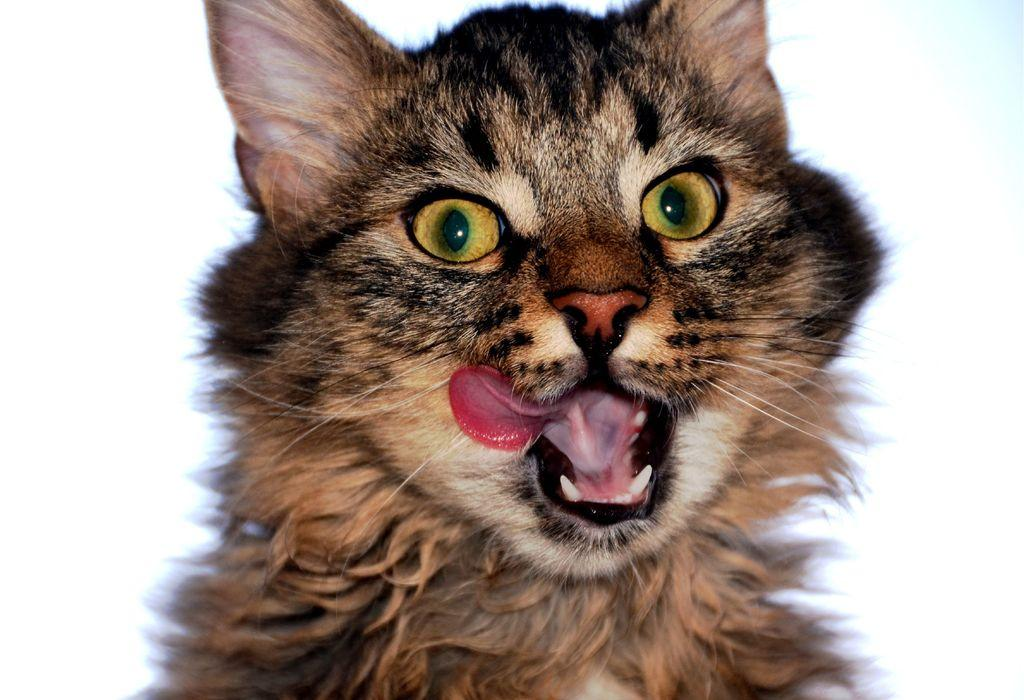What type of animal is in the image? There is a cat in the image. Can you describe the coloring of the cat? The cat has black and brown coloring. What color is the background of the image? The background of the image is white. Can you see the cat's breath in the image? There is no indication of the cat's breath in the image, as it is not visible or mentioned in the provided facts. 